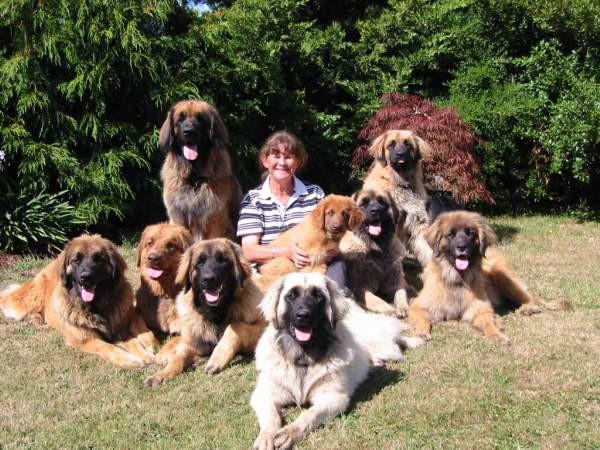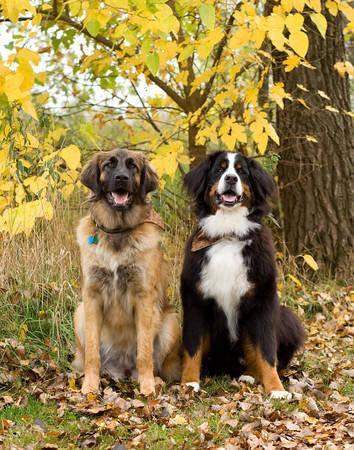The first image is the image on the left, the second image is the image on the right. Examine the images to the left and right. Is the description "One image shows at least five similar looking dogs posed sitting upright on grass in front of a house, with no humans present." accurate? Answer yes or no. No. The first image is the image on the left, the second image is the image on the right. Given the left and right images, does the statement "There are no more than two dogs in the right image." hold true? Answer yes or no. Yes. 